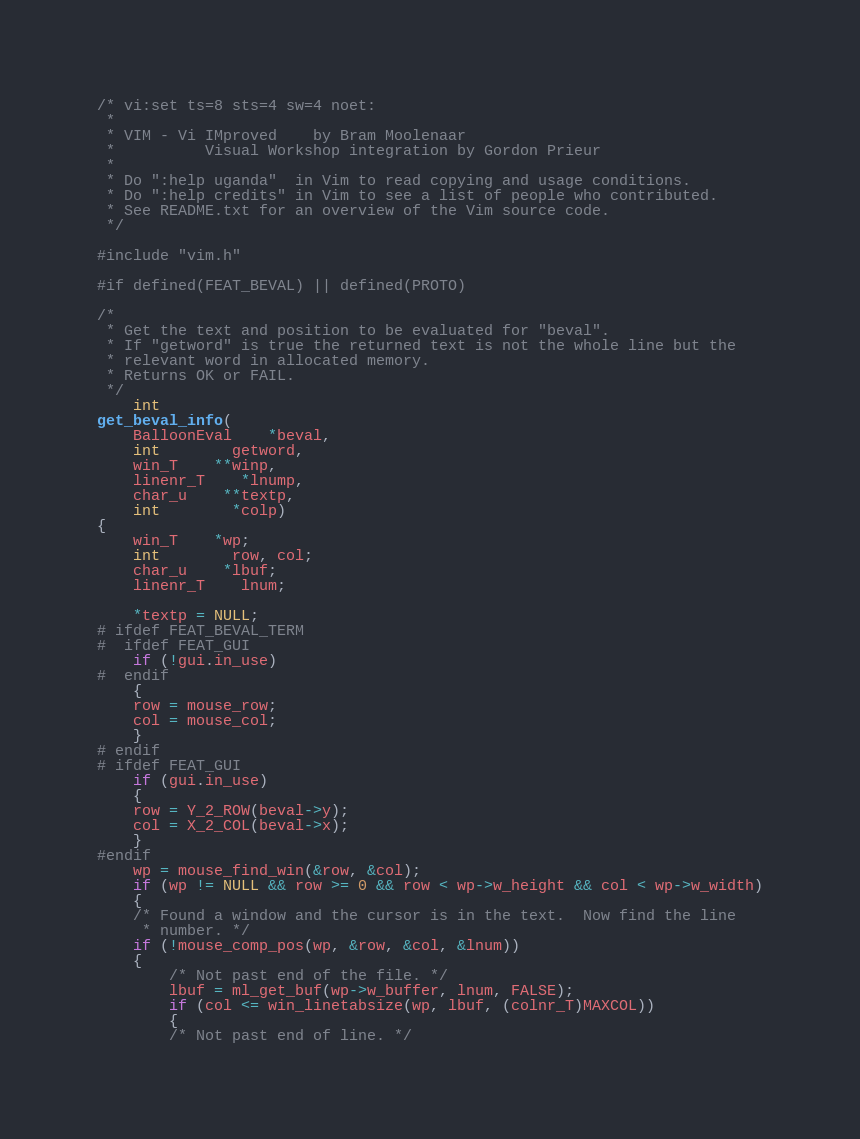Convert code to text. <code><loc_0><loc_0><loc_500><loc_500><_C_>/* vi:set ts=8 sts=4 sw=4 noet:
 *
 * VIM - Vi IMproved	by Bram Moolenaar
 *			Visual Workshop integration by Gordon Prieur
 *
 * Do ":help uganda"  in Vim to read copying and usage conditions.
 * Do ":help credits" in Vim to see a list of people who contributed.
 * See README.txt for an overview of the Vim source code.
 */

#include "vim.h"

#if defined(FEAT_BEVAL) || defined(PROTO)

/*
 * Get the text and position to be evaluated for "beval".
 * If "getword" is true the returned text is not the whole line but the
 * relevant word in allocated memory.
 * Returns OK or FAIL.
 */
    int
get_beval_info(
    BalloonEval	*beval,
    int		getword,
    win_T	**winp,
    linenr_T	*lnump,
    char_u	**textp,
    int		*colp)
{
    win_T	*wp;
    int		row, col;
    char_u	*lbuf;
    linenr_T	lnum;

    *textp = NULL;
# ifdef FEAT_BEVAL_TERM
#  ifdef FEAT_GUI
    if (!gui.in_use)
#  endif
    {
	row = mouse_row;
	col = mouse_col;
    }
# endif
# ifdef FEAT_GUI
    if (gui.in_use)
    {
	row = Y_2_ROW(beval->y);
	col = X_2_COL(beval->x);
    }
#endif
    wp = mouse_find_win(&row, &col);
    if (wp != NULL && row >= 0 && row < wp->w_height && col < wp->w_width)
    {
	/* Found a window and the cursor is in the text.  Now find the line
	 * number. */
	if (!mouse_comp_pos(wp, &row, &col, &lnum))
	{
	    /* Not past end of the file. */
	    lbuf = ml_get_buf(wp->w_buffer, lnum, FALSE);
	    if (col <= win_linetabsize(wp, lbuf, (colnr_T)MAXCOL))
	    {
		/* Not past end of line. */</code> 